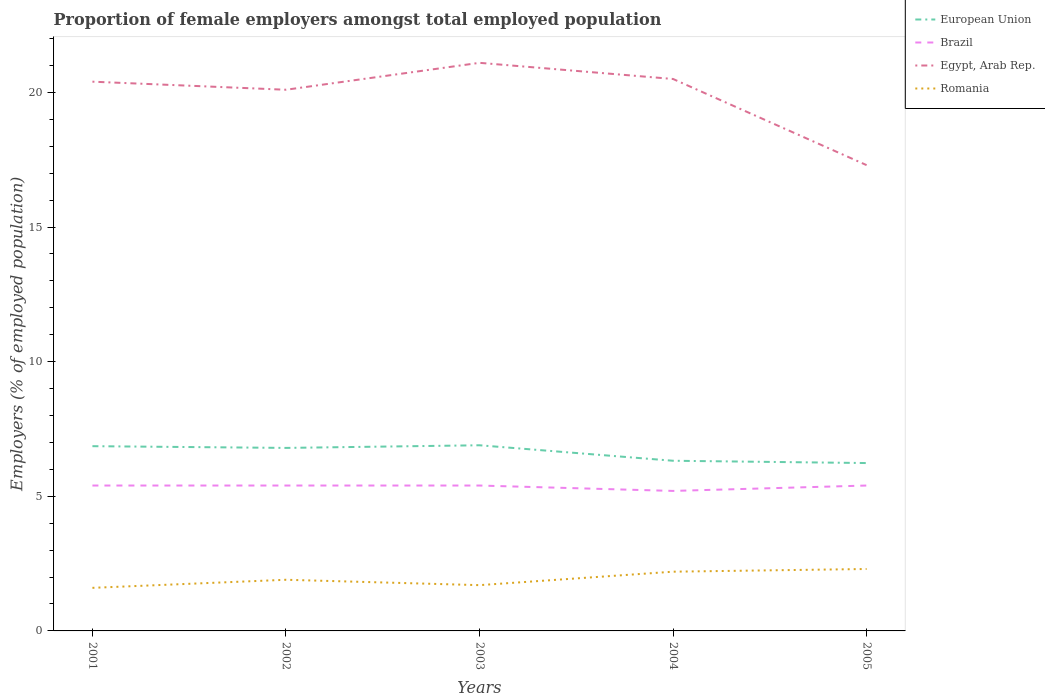Across all years, what is the maximum proportion of female employers in Brazil?
Keep it short and to the point. 5.2. What is the total proportion of female employers in European Union in the graph?
Keep it short and to the point. 0.57. What is the difference between the highest and the second highest proportion of female employers in Romania?
Make the answer very short. 0.7. What is the difference between the highest and the lowest proportion of female employers in Egypt, Arab Rep.?
Your response must be concise. 4. Is the proportion of female employers in Brazil strictly greater than the proportion of female employers in European Union over the years?
Your response must be concise. Yes. How many lines are there?
Your answer should be compact. 4. Are the values on the major ticks of Y-axis written in scientific E-notation?
Keep it short and to the point. No. What is the title of the graph?
Your answer should be compact. Proportion of female employers amongst total employed population. Does "Armenia" appear as one of the legend labels in the graph?
Provide a short and direct response. No. What is the label or title of the X-axis?
Keep it short and to the point. Years. What is the label or title of the Y-axis?
Your answer should be very brief. Employers (% of employed population). What is the Employers (% of employed population) in European Union in 2001?
Offer a terse response. 6.86. What is the Employers (% of employed population) of Brazil in 2001?
Your response must be concise. 5.4. What is the Employers (% of employed population) of Egypt, Arab Rep. in 2001?
Provide a short and direct response. 20.4. What is the Employers (% of employed population) in Romania in 2001?
Keep it short and to the point. 1.6. What is the Employers (% of employed population) in European Union in 2002?
Provide a succinct answer. 6.8. What is the Employers (% of employed population) in Brazil in 2002?
Give a very brief answer. 5.4. What is the Employers (% of employed population) of Egypt, Arab Rep. in 2002?
Make the answer very short. 20.1. What is the Employers (% of employed population) of Romania in 2002?
Your answer should be very brief. 1.9. What is the Employers (% of employed population) of European Union in 2003?
Offer a very short reply. 6.9. What is the Employers (% of employed population) of Brazil in 2003?
Provide a short and direct response. 5.4. What is the Employers (% of employed population) in Egypt, Arab Rep. in 2003?
Offer a very short reply. 21.1. What is the Employers (% of employed population) in Romania in 2003?
Offer a very short reply. 1.7. What is the Employers (% of employed population) in European Union in 2004?
Provide a succinct answer. 6.32. What is the Employers (% of employed population) in Brazil in 2004?
Your response must be concise. 5.2. What is the Employers (% of employed population) of Egypt, Arab Rep. in 2004?
Give a very brief answer. 20.5. What is the Employers (% of employed population) in Romania in 2004?
Ensure brevity in your answer.  2.2. What is the Employers (% of employed population) in European Union in 2005?
Your response must be concise. 6.23. What is the Employers (% of employed population) of Brazil in 2005?
Your answer should be very brief. 5.4. What is the Employers (% of employed population) in Egypt, Arab Rep. in 2005?
Provide a succinct answer. 17.3. What is the Employers (% of employed population) of Romania in 2005?
Keep it short and to the point. 2.3. Across all years, what is the maximum Employers (% of employed population) of European Union?
Provide a succinct answer. 6.9. Across all years, what is the maximum Employers (% of employed population) in Brazil?
Your answer should be very brief. 5.4. Across all years, what is the maximum Employers (% of employed population) of Egypt, Arab Rep.?
Provide a short and direct response. 21.1. Across all years, what is the maximum Employers (% of employed population) in Romania?
Offer a very short reply. 2.3. Across all years, what is the minimum Employers (% of employed population) of European Union?
Give a very brief answer. 6.23. Across all years, what is the minimum Employers (% of employed population) of Brazil?
Provide a succinct answer. 5.2. Across all years, what is the minimum Employers (% of employed population) of Egypt, Arab Rep.?
Make the answer very short. 17.3. Across all years, what is the minimum Employers (% of employed population) of Romania?
Make the answer very short. 1.6. What is the total Employers (% of employed population) of European Union in the graph?
Your response must be concise. 33.11. What is the total Employers (% of employed population) of Brazil in the graph?
Your response must be concise. 26.8. What is the total Employers (% of employed population) of Egypt, Arab Rep. in the graph?
Keep it short and to the point. 99.4. What is the total Employers (% of employed population) in Romania in the graph?
Ensure brevity in your answer.  9.7. What is the difference between the Employers (% of employed population) of European Union in 2001 and that in 2002?
Give a very brief answer. 0.06. What is the difference between the Employers (% of employed population) of Brazil in 2001 and that in 2002?
Ensure brevity in your answer.  0. What is the difference between the Employers (% of employed population) of Romania in 2001 and that in 2002?
Make the answer very short. -0.3. What is the difference between the Employers (% of employed population) in European Union in 2001 and that in 2003?
Your answer should be compact. -0.03. What is the difference between the Employers (% of employed population) of Egypt, Arab Rep. in 2001 and that in 2003?
Your answer should be compact. -0.7. What is the difference between the Employers (% of employed population) of Romania in 2001 and that in 2003?
Your response must be concise. -0.1. What is the difference between the Employers (% of employed population) in European Union in 2001 and that in 2004?
Provide a succinct answer. 0.54. What is the difference between the Employers (% of employed population) in Egypt, Arab Rep. in 2001 and that in 2004?
Provide a succinct answer. -0.1. What is the difference between the Employers (% of employed population) in Romania in 2001 and that in 2004?
Ensure brevity in your answer.  -0.6. What is the difference between the Employers (% of employed population) of European Union in 2001 and that in 2005?
Keep it short and to the point. 0.63. What is the difference between the Employers (% of employed population) in Egypt, Arab Rep. in 2001 and that in 2005?
Provide a short and direct response. 3.1. What is the difference between the Employers (% of employed population) of Romania in 2001 and that in 2005?
Your answer should be very brief. -0.7. What is the difference between the Employers (% of employed population) in European Union in 2002 and that in 2003?
Offer a terse response. -0.1. What is the difference between the Employers (% of employed population) in Egypt, Arab Rep. in 2002 and that in 2003?
Offer a terse response. -1. What is the difference between the Employers (% of employed population) in European Union in 2002 and that in 2004?
Offer a very short reply. 0.48. What is the difference between the Employers (% of employed population) of Brazil in 2002 and that in 2004?
Your answer should be very brief. 0.2. What is the difference between the Employers (% of employed population) of Romania in 2002 and that in 2004?
Provide a short and direct response. -0.3. What is the difference between the Employers (% of employed population) in European Union in 2002 and that in 2005?
Offer a very short reply. 0.56. What is the difference between the Employers (% of employed population) in Brazil in 2002 and that in 2005?
Ensure brevity in your answer.  0. What is the difference between the Employers (% of employed population) in Egypt, Arab Rep. in 2002 and that in 2005?
Make the answer very short. 2.8. What is the difference between the Employers (% of employed population) of Romania in 2002 and that in 2005?
Your response must be concise. -0.4. What is the difference between the Employers (% of employed population) in European Union in 2003 and that in 2004?
Provide a short and direct response. 0.57. What is the difference between the Employers (% of employed population) of Romania in 2003 and that in 2004?
Your response must be concise. -0.5. What is the difference between the Employers (% of employed population) in European Union in 2003 and that in 2005?
Offer a terse response. 0.66. What is the difference between the Employers (% of employed population) of Brazil in 2003 and that in 2005?
Provide a succinct answer. 0. What is the difference between the Employers (% of employed population) in European Union in 2004 and that in 2005?
Your response must be concise. 0.09. What is the difference between the Employers (% of employed population) of Brazil in 2004 and that in 2005?
Offer a very short reply. -0.2. What is the difference between the Employers (% of employed population) in European Union in 2001 and the Employers (% of employed population) in Brazil in 2002?
Give a very brief answer. 1.46. What is the difference between the Employers (% of employed population) in European Union in 2001 and the Employers (% of employed population) in Egypt, Arab Rep. in 2002?
Provide a short and direct response. -13.24. What is the difference between the Employers (% of employed population) in European Union in 2001 and the Employers (% of employed population) in Romania in 2002?
Give a very brief answer. 4.96. What is the difference between the Employers (% of employed population) of Brazil in 2001 and the Employers (% of employed population) of Egypt, Arab Rep. in 2002?
Your answer should be compact. -14.7. What is the difference between the Employers (% of employed population) in Egypt, Arab Rep. in 2001 and the Employers (% of employed population) in Romania in 2002?
Provide a succinct answer. 18.5. What is the difference between the Employers (% of employed population) of European Union in 2001 and the Employers (% of employed population) of Brazil in 2003?
Offer a very short reply. 1.46. What is the difference between the Employers (% of employed population) of European Union in 2001 and the Employers (% of employed population) of Egypt, Arab Rep. in 2003?
Keep it short and to the point. -14.24. What is the difference between the Employers (% of employed population) in European Union in 2001 and the Employers (% of employed population) in Romania in 2003?
Offer a very short reply. 5.16. What is the difference between the Employers (% of employed population) in Brazil in 2001 and the Employers (% of employed population) in Egypt, Arab Rep. in 2003?
Offer a very short reply. -15.7. What is the difference between the Employers (% of employed population) of Egypt, Arab Rep. in 2001 and the Employers (% of employed population) of Romania in 2003?
Your answer should be very brief. 18.7. What is the difference between the Employers (% of employed population) of European Union in 2001 and the Employers (% of employed population) of Brazil in 2004?
Your response must be concise. 1.66. What is the difference between the Employers (% of employed population) of European Union in 2001 and the Employers (% of employed population) of Egypt, Arab Rep. in 2004?
Offer a terse response. -13.64. What is the difference between the Employers (% of employed population) of European Union in 2001 and the Employers (% of employed population) of Romania in 2004?
Provide a short and direct response. 4.66. What is the difference between the Employers (% of employed population) in Brazil in 2001 and the Employers (% of employed population) in Egypt, Arab Rep. in 2004?
Offer a very short reply. -15.1. What is the difference between the Employers (% of employed population) of Brazil in 2001 and the Employers (% of employed population) of Romania in 2004?
Offer a terse response. 3.2. What is the difference between the Employers (% of employed population) in European Union in 2001 and the Employers (% of employed population) in Brazil in 2005?
Provide a succinct answer. 1.46. What is the difference between the Employers (% of employed population) in European Union in 2001 and the Employers (% of employed population) in Egypt, Arab Rep. in 2005?
Your answer should be very brief. -10.44. What is the difference between the Employers (% of employed population) of European Union in 2001 and the Employers (% of employed population) of Romania in 2005?
Give a very brief answer. 4.56. What is the difference between the Employers (% of employed population) in Brazil in 2001 and the Employers (% of employed population) in Egypt, Arab Rep. in 2005?
Offer a terse response. -11.9. What is the difference between the Employers (% of employed population) of European Union in 2002 and the Employers (% of employed population) of Brazil in 2003?
Provide a short and direct response. 1.4. What is the difference between the Employers (% of employed population) of European Union in 2002 and the Employers (% of employed population) of Egypt, Arab Rep. in 2003?
Make the answer very short. -14.3. What is the difference between the Employers (% of employed population) in European Union in 2002 and the Employers (% of employed population) in Romania in 2003?
Give a very brief answer. 5.1. What is the difference between the Employers (% of employed population) of Brazil in 2002 and the Employers (% of employed population) of Egypt, Arab Rep. in 2003?
Give a very brief answer. -15.7. What is the difference between the Employers (% of employed population) in European Union in 2002 and the Employers (% of employed population) in Brazil in 2004?
Make the answer very short. 1.6. What is the difference between the Employers (% of employed population) of European Union in 2002 and the Employers (% of employed population) of Egypt, Arab Rep. in 2004?
Offer a very short reply. -13.7. What is the difference between the Employers (% of employed population) in European Union in 2002 and the Employers (% of employed population) in Romania in 2004?
Make the answer very short. 4.6. What is the difference between the Employers (% of employed population) in Brazil in 2002 and the Employers (% of employed population) in Egypt, Arab Rep. in 2004?
Your response must be concise. -15.1. What is the difference between the Employers (% of employed population) in Brazil in 2002 and the Employers (% of employed population) in Romania in 2004?
Offer a terse response. 3.2. What is the difference between the Employers (% of employed population) of Egypt, Arab Rep. in 2002 and the Employers (% of employed population) of Romania in 2004?
Make the answer very short. 17.9. What is the difference between the Employers (% of employed population) in European Union in 2002 and the Employers (% of employed population) in Brazil in 2005?
Offer a terse response. 1.4. What is the difference between the Employers (% of employed population) of European Union in 2002 and the Employers (% of employed population) of Egypt, Arab Rep. in 2005?
Offer a terse response. -10.5. What is the difference between the Employers (% of employed population) in European Union in 2002 and the Employers (% of employed population) in Romania in 2005?
Your response must be concise. 4.5. What is the difference between the Employers (% of employed population) of Brazil in 2002 and the Employers (% of employed population) of Romania in 2005?
Provide a succinct answer. 3.1. What is the difference between the Employers (% of employed population) of European Union in 2003 and the Employers (% of employed population) of Brazil in 2004?
Your answer should be compact. 1.7. What is the difference between the Employers (% of employed population) in European Union in 2003 and the Employers (% of employed population) in Egypt, Arab Rep. in 2004?
Make the answer very short. -13.6. What is the difference between the Employers (% of employed population) of European Union in 2003 and the Employers (% of employed population) of Romania in 2004?
Your response must be concise. 4.7. What is the difference between the Employers (% of employed population) of Brazil in 2003 and the Employers (% of employed population) of Egypt, Arab Rep. in 2004?
Your answer should be very brief. -15.1. What is the difference between the Employers (% of employed population) in Egypt, Arab Rep. in 2003 and the Employers (% of employed population) in Romania in 2004?
Your answer should be compact. 18.9. What is the difference between the Employers (% of employed population) in European Union in 2003 and the Employers (% of employed population) in Brazil in 2005?
Give a very brief answer. 1.5. What is the difference between the Employers (% of employed population) of European Union in 2003 and the Employers (% of employed population) of Egypt, Arab Rep. in 2005?
Provide a succinct answer. -10.4. What is the difference between the Employers (% of employed population) of European Union in 2003 and the Employers (% of employed population) of Romania in 2005?
Offer a very short reply. 4.6. What is the difference between the Employers (% of employed population) of European Union in 2004 and the Employers (% of employed population) of Brazil in 2005?
Make the answer very short. 0.92. What is the difference between the Employers (% of employed population) in European Union in 2004 and the Employers (% of employed population) in Egypt, Arab Rep. in 2005?
Your response must be concise. -10.98. What is the difference between the Employers (% of employed population) in European Union in 2004 and the Employers (% of employed population) in Romania in 2005?
Offer a very short reply. 4.02. What is the difference between the Employers (% of employed population) in Egypt, Arab Rep. in 2004 and the Employers (% of employed population) in Romania in 2005?
Keep it short and to the point. 18.2. What is the average Employers (% of employed population) of European Union per year?
Offer a terse response. 6.62. What is the average Employers (% of employed population) of Brazil per year?
Your answer should be compact. 5.36. What is the average Employers (% of employed population) of Egypt, Arab Rep. per year?
Ensure brevity in your answer.  19.88. What is the average Employers (% of employed population) of Romania per year?
Make the answer very short. 1.94. In the year 2001, what is the difference between the Employers (% of employed population) in European Union and Employers (% of employed population) in Brazil?
Provide a short and direct response. 1.46. In the year 2001, what is the difference between the Employers (% of employed population) in European Union and Employers (% of employed population) in Egypt, Arab Rep.?
Make the answer very short. -13.54. In the year 2001, what is the difference between the Employers (% of employed population) of European Union and Employers (% of employed population) of Romania?
Make the answer very short. 5.26. In the year 2001, what is the difference between the Employers (% of employed population) of Brazil and Employers (% of employed population) of Romania?
Provide a short and direct response. 3.8. In the year 2002, what is the difference between the Employers (% of employed population) in European Union and Employers (% of employed population) in Brazil?
Make the answer very short. 1.4. In the year 2002, what is the difference between the Employers (% of employed population) in European Union and Employers (% of employed population) in Egypt, Arab Rep.?
Provide a short and direct response. -13.3. In the year 2002, what is the difference between the Employers (% of employed population) of European Union and Employers (% of employed population) of Romania?
Your answer should be compact. 4.9. In the year 2002, what is the difference between the Employers (% of employed population) in Brazil and Employers (% of employed population) in Egypt, Arab Rep.?
Ensure brevity in your answer.  -14.7. In the year 2002, what is the difference between the Employers (% of employed population) in Brazil and Employers (% of employed population) in Romania?
Give a very brief answer. 3.5. In the year 2003, what is the difference between the Employers (% of employed population) in European Union and Employers (% of employed population) in Brazil?
Offer a terse response. 1.5. In the year 2003, what is the difference between the Employers (% of employed population) in European Union and Employers (% of employed population) in Egypt, Arab Rep.?
Offer a terse response. -14.2. In the year 2003, what is the difference between the Employers (% of employed population) of European Union and Employers (% of employed population) of Romania?
Provide a succinct answer. 5.2. In the year 2003, what is the difference between the Employers (% of employed population) of Brazil and Employers (% of employed population) of Egypt, Arab Rep.?
Your answer should be compact. -15.7. In the year 2004, what is the difference between the Employers (% of employed population) in European Union and Employers (% of employed population) in Brazil?
Your response must be concise. 1.12. In the year 2004, what is the difference between the Employers (% of employed population) of European Union and Employers (% of employed population) of Egypt, Arab Rep.?
Provide a short and direct response. -14.18. In the year 2004, what is the difference between the Employers (% of employed population) in European Union and Employers (% of employed population) in Romania?
Provide a short and direct response. 4.12. In the year 2004, what is the difference between the Employers (% of employed population) of Brazil and Employers (% of employed population) of Egypt, Arab Rep.?
Provide a succinct answer. -15.3. In the year 2005, what is the difference between the Employers (% of employed population) of European Union and Employers (% of employed population) of Brazil?
Ensure brevity in your answer.  0.83. In the year 2005, what is the difference between the Employers (% of employed population) in European Union and Employers (% of employed population) in Egypt, Arab Rep.?
Your answer should be compact. -11.07. In the year 2005, what is the difference between the Employers (% of employed population) in European Union and Employers (% of employed population) in Romania?
Give a very brief answer. 3.93. In the year 2005, what is the difference between the Employers (% of employed population) of Brazil and Employers (% of employed population) of Egypt, Arab Rep.?
Ensure brevity in your answer.  -11.9. In the year 2005, what is the difference between the Employers (% of employed population) of Brazil and Employers (% of employed population) of Romania?
Your answer should be compact. 3.1. In the year 2005, what is the difference between the Employers (% of employed population) in Egypt, Arab Rep. and Employers (% of employed population) in Romania?
Ensure brevity in your answer.  15. What is the ratio of the Employers (% of employed population) of European Union in 2001 to that in 2002?
Ensure brevity in your answer.  1.01. What is the ratio of the Employers (% of employed population) in Egypt, Arab Rep. in 2001 to that in 2002?
Make the answer very short. 1.01. What is the ratio of the Employers (% of employed population) in Romania in 2001 to that in 2002?
Your answer should be compact. 0.84. What is the ratio of the Employers (% of employed population) of European Union in 2001 to that in 2003?
Make the answer very short. 1. What is the ratio of the Employers (% of employed population) of Egypt, Arab Rep. in 2001 to that in 2003?
Provide a short and direct response. 0.97. What is the ratio of the Employers (% of employed population) in European Union in 2001 to that in 2004?
Your answer should be very brief. 1.09. What is the ratio of the Employers (% of employed population) in Egypt, Arab Rep. in 2001 to that in 2004?
Offer a terse response. 1. What is the ratio of the Employers (% of employed population) of Romania in 2001 to that in 2004?
Make the answer very short. 0.73. What is the ratio of the Employers (% of employed population) in European Union in 2001 to that in 2005?
Ensure brevity in your answer.  1.1. What is the ratio of the Employers (% of employed population) of Brazil in 2001 to that in 2005?
Give a very brief answer. 1. What is the ratio of the Employers (% of employed population) in Egypt, Arab Rep. in 2001 to that in 2005?
Give a very brief answer. 1.18. What is the ratio of the Employers (% of employed population) of Romania in 2001 to that in 2005?
Ensure brevity in your answer.  0.7. What is the ratio of the Employers (% of employed population) in European Union in 2002 to that in 2003?
Give a very brief answer. 0.99. What is the ratio of the Employers (% of employed population) in Egypt, Arab Rep. in 2002 to that in 2003?
Your answer should be compact. 0.95. What is the ratio of the Employers (% of employed population) of Romania in 2002 to that in 2003?
Provide a succinct answer. 1.12. What is the ratio of the Employers (% of employed population) of European Union in 2002 to that in 2004?
Make the answer very short. 1.08. What is the ratio of the Employers (% of employed population) of Egypt, Arab Rep. in 2002 to that in 2004?
Give a very brief answer. 0.98. What is the ratio of the Employers (% of employed population) of Romania in 2002 to that in 2004?
Your answer should be compact. 0.86. What is the ratio of the Employers (% of employed population) of European Union in 2002 to that in 2005?
Give a very brief answer. 1.09. What is the ratio of the Employers (% of employed population) of Brazil in 2002 to that in 2005?
Ensure brevity in your answer.  1. What is the ratio of the Employers (% of employed population) in Egypt, Arab Rep. in 2002 to that in 2005?
Give a very brief answer. 1.16. What is the ratio of the Employers (% of employed population) in Romania in 2002 to that in 2005?
Ensure brevity in your answer.  0.83. What is the ratio of the Employers (% of employed population) of European Union in 2003 to that in 2004?
Give a very brief answer. 1.09. What is the ratio of the Employers (% of employed population) in Brazil in 2003 to that in 2004?
Your answer should be compact. 1.04. What is the ratio of the Employers (% of employed population) in Egypt, Arab Rep. in 2003 to that in 2004?
Provide a succinct answer. 1.03. What is the ratio of the Employers (% of employed population) of Romania in 2003 to that in 2004?
Give a very brief answer. 0.77. What is the ratio of the Employers (% of employed population) in European Union in 2003 to that in 2005?
Your response must be concise. 1.11. What is the ratio of the Employers (% of employed population) of Brazil in 2003 to that in 2005?
Keep it short and to the point. 1. What is the ratio of the Employers (% of employed population) in Egypt, Arab Rep. in 2003 to that in 2005?
Your answer should be very brief. 1.22. What is the ratio of the Employers (% of employed population) in Romania in 2003 to that in 2005?
Make the answer very short. 0.74. What is the ratio of the Employers (% of employed population) of European Union in 2004 to that in 2005?
Give a very brief answer. 1.01. What is the ratio of the Employers (% of employed population) in Brazil in 2004 to that in 2005?
Your answer should be very brief. 0.96. What is the ratio of the Employers (% of employed population) of Egypt, Arab Rep. in 2004 to that in 2005?
Your answer should be compact. 1.19. What is the ratio of the Employers (% of employed population) in Romania in 2004 to that in 2005?
Your answer should be compact. 0.96. What is the difference between the highest and the second highest Employers (% of employed population) in European Union?
Provide a succinct answer. 0.03. What is the difference between the highest and the second highest Employers (% of employed population) of Brazil?
Provide a succinct answer. 0. What is the difference between the highest and the lowest Employers (% of employed population) in European Union?
Offer a terse response. 0.66. What is the difference between the highest and the lowest Employers (% of employed population) of Brazil?
Your answer should be very brief. 0.2. What is the difference between the highest and the lowest Employers (% of employed population) in Egypt, Arab Rep.?
Offer a terse response. 3.8. 